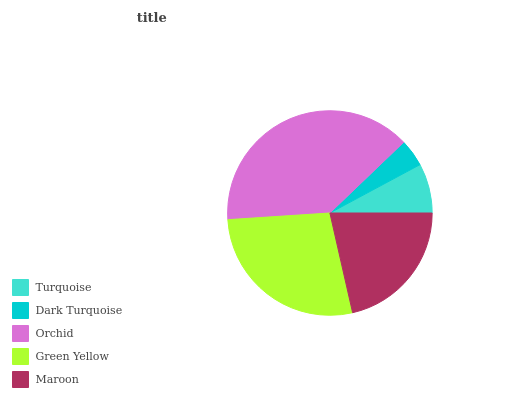Is Dark Turquoise the minimum?
Answer yes or no. Yes. Is Orchid the maximum?
Answer yes or no. Yes. Is Orchid the minimum?
Answer yes or no. No. Is Dark Turquoise the maximum?
Answer yes or no. No. Is Orchid greater than Dark Turquoise?
Answer yes or no. Yes. Is Dark Turquoise less than Orchid?
Answer yes or no. Yes. Is Dark Turquoise greater than Orchid?
Answer yes or no. No. Is Orchid less than Dark Turquoise?
Answer yes or no. No. Is Maroon the high median?
Answer yes or no. Yes. Is Maroon the low median?
Answer yes or no. Yes. Is Orchid the high median?
Answer yes or no. No. Is Green Yellow the low median?
Answer yes or no. No. 